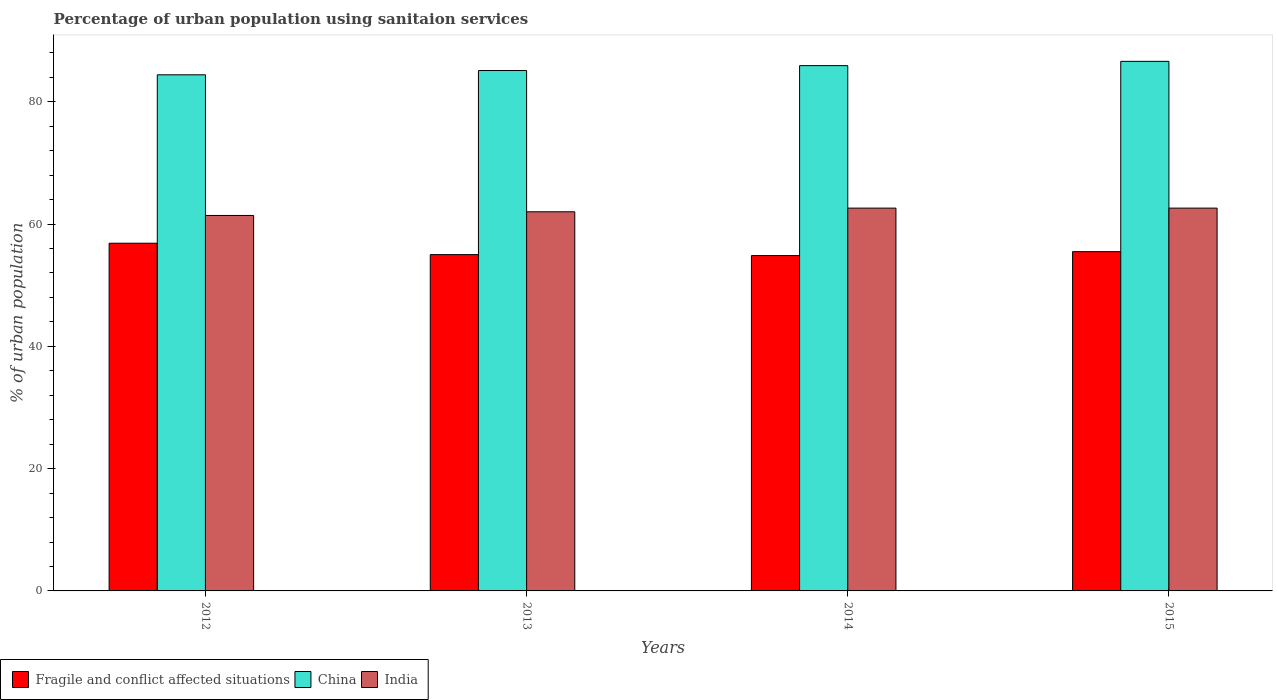How many groups of bars are there?
Offer a terse response. 4. Are the number of bars on each tick of the X-axis equal?
Your response must be concise. Yes. What is the label of the 2nd group of bars from the left?
Ensure brevity in your answer.  2013. What is the percentage of urban population using sanitaion services in India in 2012?
Offer a terse response. 61.4. Across all years, what is the maximum percentage of urban population using sanitaion services in India?
Offer a terse response. 62.6. Across all years, what is the minimum percentage of urban population using sanitaion services in China?
Make the answer very short. 84.4. In which year was the percentage of urban population using sanitaion services in Fragile and conflict affected situations maximum?
Offer a very short reply. 2012. In which year was the percentage of urban population using sanitaion services in China minimum?
Offer a very short reply. 2012. What is the total percentage of urban population using sanitaion services in China in the graph?
Provide a short and direct response. 342. What is the difference between the percentage of urban population using sanitaion services in China in 2013 and that in 2014?
Your answer should be compact. -0.8. What is the difference between the percentage of urban population using sanitaion services in China in 2014 and the percentage of urban population using sanitaion services in India in 2012?
Your answer should be compact. 24.5. What is the average percentage of urban population using sanitaion services in India per year?
Keep it short and to the point. 62.15. In the year 2014, what is the difference between the percentage of urban population using sanitaion services in India and percentage of urban population using sanitaion services in China?
Offer a very short reply. -23.3. What is the ratio of the percentage of urban population using sanitaion services in China in 2014 to that in 2015?
Keep it short and to the point. 0.99. Is the percentage of urban population using sanitaion services in India in 2013 less than that in 2015?
Offer a very short reply. Yes. What is the difference between the highest and the second highest percentage of urban population using sanitaion services in China?
Give a very brief answer. 0.7. What is the difference between the highest and the lowest percentage of urban population using sanitaion services in Fragile and conflict affected situations?
Provide a succinct answer. 2.02. Is the sum of the percentage of urban population using sanitaion services in Fragile and conflict affected situations in 2014 and 2015 greater than the maximum percentage of urban population using sanitaion services in India across all years?
Keep it short and to the point. Yes. What does the 3rd bar from the left in 2014 represents?
Provide a short and direct response. India. What does the 2nd bar from the right in 2012 represents?
Your answer should be compact. China. Is it the case that in every year, the sum of the percentage of urban population using sanitaion services in Fragile and conflict affected situations and percentage of urban population using sanitaion services in China is greater than the percentage of urban population using sanitaion services in India?
Ensure brevity in your answer.  Yes. Are all the bars in the graph horizontal?
Keep it short and to the point. No. How many years are there in the graph?
Provide a short and direct response. 4. Where does the legend appear in the graph?
Your answer should be compact. Bottom left. What is the title of the graph?
Provide a succinct answer. Percentage of urban population using sanitaion services. What is the label or title of the Y-axis?
Provide a succinct answer. % of urban population. What is the % of urban population of Fragile and conflict affected situations in 2012?
Provide a succinct answer. 56.86. What is the % of urban population in China in 2012?
Provide a short and direct response. 84.4. What is the % of urban population in India in 2012?
Your answer should be very brief. 61.4. What is the % of urban population in Fragile and conflict affected situations in 2013?
Provide a short and direct response. 55. What is the % of urban population in China in 2013?
Offer a terse response. 85.1. What is the % of urban population in Fragile and conflict affected situations in 2014?
Your answer should be very brief. 54.84. What is the % of urban population in China in 2014?
Ensure brevity in your answer.  85.9. What is the % of urban population of India in 2014?
Offer a very short reply. 62.6. What is the % of urban population in Fragile and conflict affected situations in 2015?
Give a very brief answer. 55.48. What is the % of urban population in China in 2015?
Offer a terse response. 86.6. What is the % of urban population in India in 2015?
Make the answer very short. 62.6. Across all years, what is the maximum % of urban population of Fragile and conflict affected situations?
Your answer should be compact. 56.86. Across all years, what is the maximum % of urban population of China?
Make the answer very short. 86.6. Across all years, what is the maximum % of urban population in India?
Ensure brevity in your answer.  62.6. Across all years, what is the minimum % of urban population in Fragile and conflict affected situations?
Your response must be concise. 54.84. Across all years, what is the minimum % of urban population of China?
Make the answer very short. 84.4. Across all years, what is the minimum % of urban population of India?
Make the answer very short. 61.4. What is the total % of urban population in Fragile and conflict affected situations in the graph?
Offer a terse response. 222.17. What is the total % of urban population of China in the graph?
Give a very brief answer. 342. What is the total % of urban population in India in the graph?
Ensure brevity in your answer.  248.6. What is the difference between the % of urban population in Fragile and conflict affected situations in 2012 and that in 2013?
Your response must be concise. 1.86. What is the difference between the % of urban population of Fragile and conflict affected situations in 2012 and that in 2014?
Offer a very short reply. 2.02. What is the difference between the % of urban population in India in 2012 and that in 2014?
Your answer should be very brief. -1.2. What is the difference between the % of urban population in Fragile and conflict affected situations in 2012 and that in 2015?
Ensure brevity in your answer.  1.38. What is the difference between the % of urban population in Fragile and conflict affected situations in 2013 and that in 2014?
Ensure brevity in your answer.  0.16. What is the difference between the % of urban population of India in 2013 and that in 2014?
Ensure brevity in your answer.  -0.6. What is the difference between the % of urban population in Fragile and conflict affected situations in 2013 and that in 2015?
Provide a succinct answer. -0.49. What is the difference between the % of urban population of China in 2013 and that in 2015?
Your answer should be compact. -1.5. What is the difference between the % of urban population in Fragile and conflict affected situations in 2014 and that in 2015?
Your response must be concise. -0.64. What is the difference between the % of urban population in China in 2014 and that in 2015?
Your answer should be compact. -0.7. What is the difference between the % of urban population in India in 2014 and that in 2015?
Give a very brief answer. 0. What is the difference between the % of urban population of Fragile and conflict affected situations in 2012 and the % of urban population of China in 2013?
Keep it short and to the point. -28.24. What is the difference between the % of urban population in Fragile and conflict affected situations in 2012 and the % of urban population in India in 2013?
Offer a very short reply. -5.14. What is the difference between the % of urban population in China in 2012 and the % of urban population in India in 2013?
Make the answer very short. 22.4. What is the difference between the % of urban population of Fragile and conflict affected situations in 2012 and the % of urban population of China in 2014?
Provide a succinct answer. -29.04. What is the difference between the % of urban population in Fragile and conflict affected situations in 2012 and the % of urban population in India in 2014?
Keep it short and to the point. -5.74. What is the difference between the % of urban population in China in 2012 and the % of urban population in India in 2014?
Offer a very short reply. 21.8. What is the difference between the % of urban population in Fragile and conflict affected situations in 2012 and the % of urban population in China in 2015?
Your answer should be very brief. -29.74. What is the difference between the % of urban population of Fragile and conflict affected situations in 2012 and the % of urban population of India in 2015?
Provide a short and direct response. -5.74. What is the difference between the % of urban population of China in 2012 and the % of urban population of India in 2015?
Your response must be concise. 21.8. What is the difference between the % of urban population of Fragile and conflict affected situations in 2013 and the % of urban population of China in 2014?
Keep it short and to the point. -30.91. What is the difference between the % of urban population of Fragile and conflict affected situations in 2013 and the % of urban population of India in 2014?
Keep it short and to the point. -7.61. What is the difference between the % of urban population in China in 2013 and the % of urban population in India in 2014?
Make the answer very short. 22.5. What is the difference between the % of urban population in Fragile and conflict affected situations in 2013 and the % of urban population in China in 2015?
Offer a very short reply. -31.61. What is the difference between the % of urban population of Fragile and conflict affected situations in 2013 and the % of urban population of India in 2015?
Provide a succinct answer. -7.61. What is the difference between the % of urban population of Fragile and conflict affected situations in 2014 and the % of urban population of China in 2015?
Offer a terse response. -31.76. What is the difference between the % of urban population in Fragile and conflict affected situations in 2014 and the % of urban population in India in 2015?
Offer a very short reply. -7.76. What is the difference between the % of urban population in China in 2014 and the % of urban population in India in 2015?
Keep it short and to the point. 23.3. What is the average % of urban population of Fragile and conflict affected situations per year?
Keep it short and to the point. 55.54. What is the average % of urban population of China per year?
Keep it short and to the point. 85.5. What is the average % of urban population in India per year?
Offer a terse response. 62.15. In the year 2012, what is the difference between the % of urban population in Fragile and conflict affected situations and % of urban population in China?
Offer a very short reply. -27.54. In the year 2012, what is the difference between the % of urban population of Fragile and conflict affected situations and % of urban population of India?
Provide a short and direct response. -4.54. In the year 2013, what is the difference between the % of urban population in Fragile and conflict affected situations and % of urban population in China?
Make the answer very short. -30.11. In the year 2013, what is the difference between the % of urban population of Fragile and conflict affected situations and % of urban population of India?
Offer a very short reply. -7. In the year 2013, what is the difference between the % of urban population of China and % of urban population of India?
Ensure brevity in your answer.  23.1. In the year 2014, what is the difference between the % of urban population in Fragile and conflict affected situations and % of urban population in China?
Ensure brevity in your answer.  -31.06. In the year 2014, what is the difference between the % of urban population in Fragile and conflict affected situations and % of urban population in India?
Offer a very short reply. -7.76. In the year 2014, what is the difference between the % of urban population in China and % of urban population in India?
Give a very brief answer. 23.3. In the year 2015, what is the difference between the % of urban population of Fragile and conflict affected situations and % of urban population of China?
Provide a short and direct response. -31.12. In the year 2015, what is the difference between the % of urban population in Fragile and conflict affected situations and % of urban population in India?
Provide a short and direct response. -7.12. In the year 2015, what is the difference between the % of urban population in China and % of urban population in India?
Make the answer very short. 24. What is the ratio of the % of urban population in Fragile and conflict affected situations in 2012 to that in 2013?
Provide a short and direct response. 1.03. What is the ratio of the % of urban population in China in 2012 to that in 2013?
Your response must be concise. 0.99. What is the ratio of the % of urban population of India in 2012 to that in 2013?
Ensure brevity in your answer.  0.99. What is the ratio of the % of urban population of Fragile and conflict affected situations in 2012 to that in 2014?
Provide a succinct answer. 1.04. What is the ratio of the % of urban population in China in 2012 to that in 2014?
Keep it short and to the point. 0.98. What is the ratio of the % of urban population in India in 2012 to that in 2014?
Your answer should be compact. 0.98. What is the ratio of the % of urban population in Fragile and conflict affected situations in 2012 to that in 2015?
Give a very brief answer. 1.02. What is the ratio of the % of urban population in China in 2012 to that in 2015?
Offer a terse response. 0.97. What is the ratio of the % of urban population in India in 2012 to that in 2015?
Your answer should be compact. 0.98. What is the ratio of the % of urban population in China in 2013 to that in 2014?
Your answer should be very brief. 0.99. What is the ratio of the % of urban population of China in 2013 to that in 2015?
Provide a succinct answer. 0.98. What is the ratio of the % of urban population in India in 2013 to that in 2015?
Your answer should be very brief. 0.99. What is the ratio of the % of urban population of Fragile and conflict affected situations in 2014 to that in 2015?
Keep it short and to the point. 0.99. What is the ratio of the % of urban population of China in 2014 to that in 2015?
Your answer should be very brief. 0.99. What is the difference between the highest and the second highest % of urban population in Fragile and conflict affected situations?
Your answer should be compact. 1.38. What is the difference between the highest and the lowest % of urban population of Fragile and conflict affected situations?
Provide a short and direct response. 2.02. What is the difference between the highest and the lowest % of urban population in China?
Your answer should be compact. 2.2. What is the difference between the highest and the lowest % of urban population in India?
Your response must be concise. 1.2. 